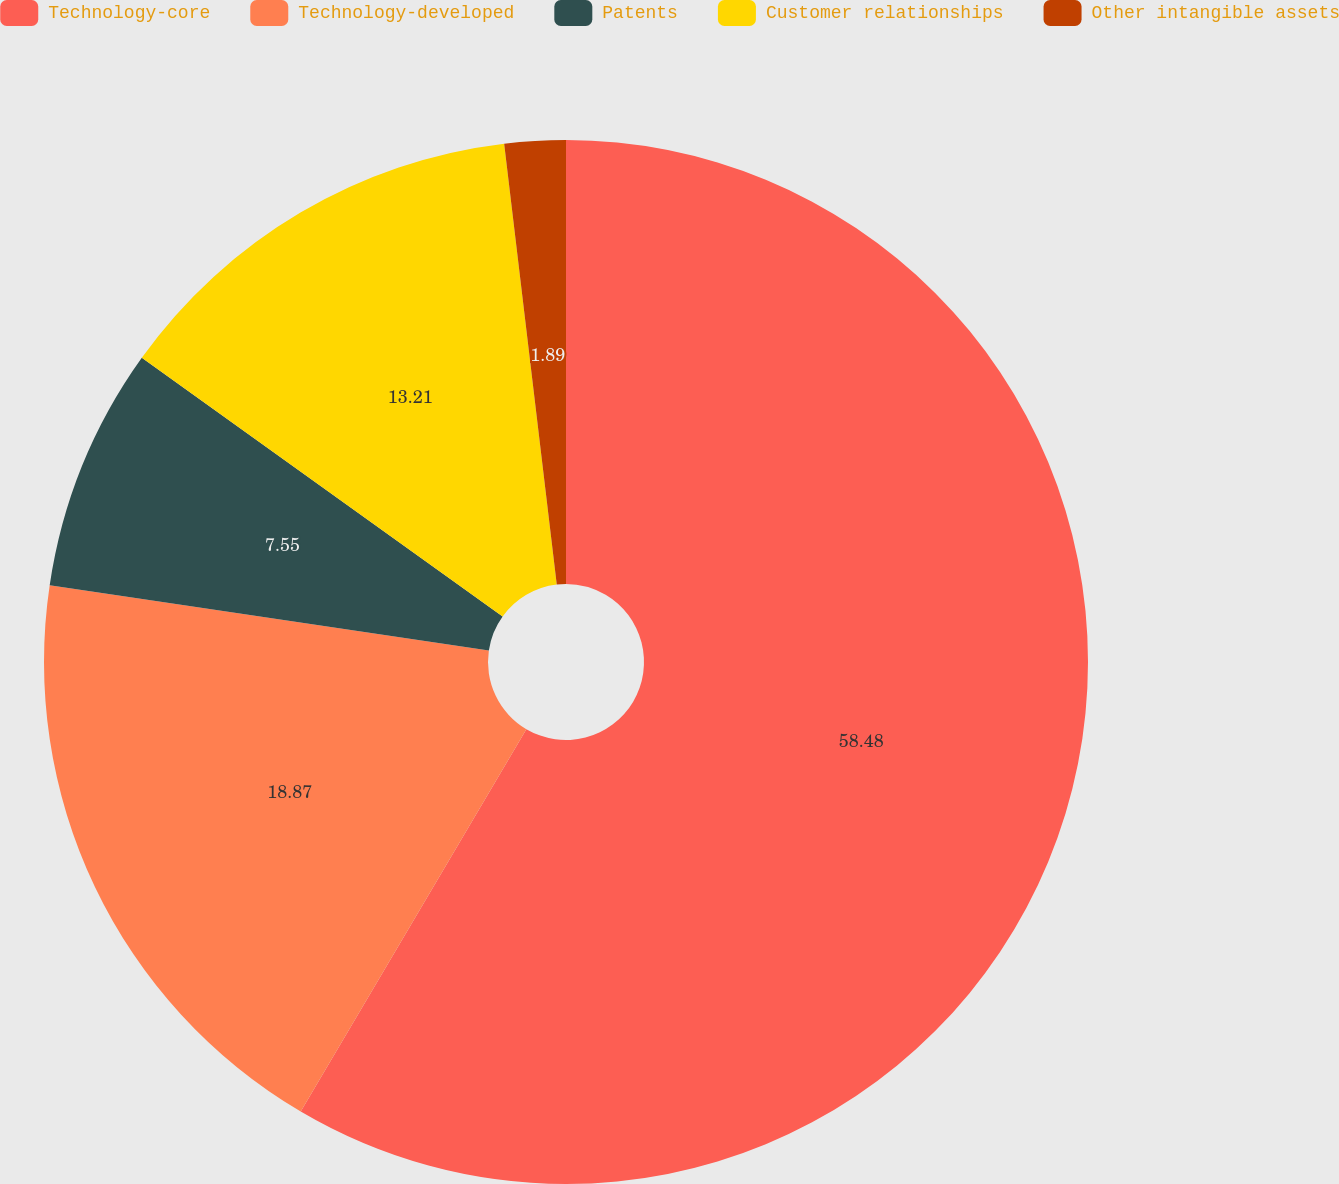Convert chart to OTSL. <chart><loc_0><loc_0><loc_500><loc_500><pie_chart><fcel>Technology-core<fcel>Technology-developed<fcel>Patents<fcel>Customer relationships<fcel>Other intangible assets<nl><fcel>58.49%<fcel>18.87%<fcel>7.55%<fcel>13.21%<fcel>1.89%<nl></chart> 